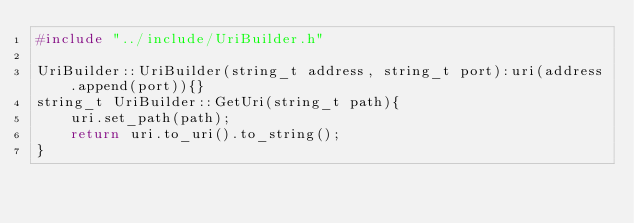<code> <loc_0><loc_0><loc_500><loc_500><_C++_>#include "../include/UriBuilder.h"

UriBuilder::UriBuilder(string_t address, string_t port):uri(address.append(port)){}
string_t UriBuilder::GetUri(string_t path){
    uri.set_path(path);
    return uri.to_uri().to_string();
}</code> 